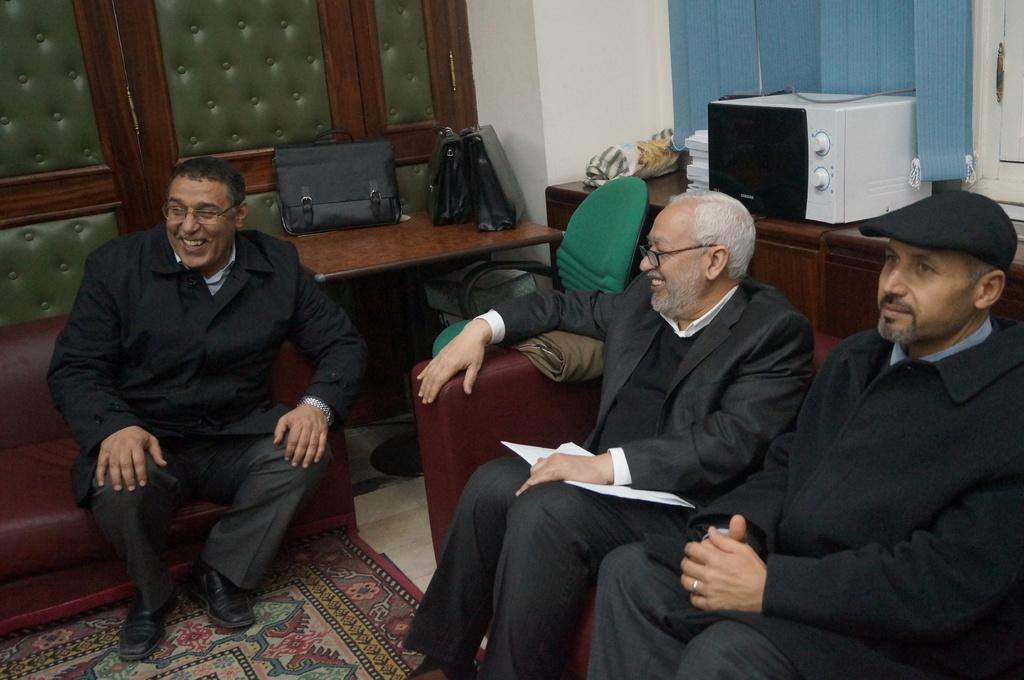How many people are sitting in the image? There are three persons sitting on couches in the image. What can be seen besides the people sitting on the couches? There are bags, tables, a chair, and a microwave oven in the image. Can you describe the furniture in the image? There are couches, tables, and a chair in the image. What type of appliance is present in the image? There is a microwave oven in the image. What other unspecified objects can be seen in the image? There are some unspecified objects in the image. What type of mint is growing on the border of the image? There is no mint or border present in the image; it only features three persons sitting on couches, bags, tables, a chair, a microwave oven, and some unspecified objects. 